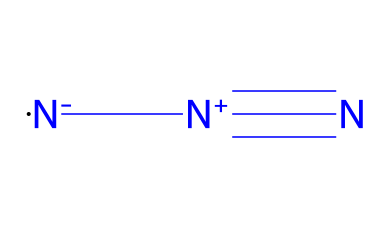how many nitrogen atoms are present in hydrazoic acid? The SMILES representation shows three nitrogen atoms (N) in a sequence, confirming that they are all part of the hydrazoic acid structure.
Answer: three what is the total charge of hydrazoic acid? Analyzing the SMILES notation, there is a positive charge indicated by [N+] and a negative charge indicated by [N-], which together sum to zero, resulting in a neutral molecule.
Answer: zero what is the name of the chemical represented by this structure? The SMILES notation corresponds to hydrazoic acid (N3H), which is a well-known azide compound.
Answer: hydrazoic acid which functional group is present in azides? The presence of the -N3 group in the chemical structure indicates that the compound belongs to the class of azides, which is defined by having a nitrogen functional group.
Answer: azide what type of bonds are present between the nitrogen atoms in hydrazoic acid? The structure reveals that the nitrogen atoms are connected by a triple bond (denoted by # in SMILES), which is characteristic of multiple bonding in nitrogen compounds.
Answer: triple bonds how does the structure of hydrazoic acid relate to its reactivity in chemical reactions? The presence of multiple nitrogen atoms with high electronegativity and a unique arrangement allows for significant reactivity, especially in producing other azides, because azides typically have good nucleophilic properties.
Answer: high reactivity what industrial applications are associated with azide compounds? Azides like hydrazoic acid are widely used in manufacturing explosives, pharmaceuticals, and agricultural chemicals due to their reactive nature and ability to transfer nitrogen atoms effectively.
Answer: explosives 